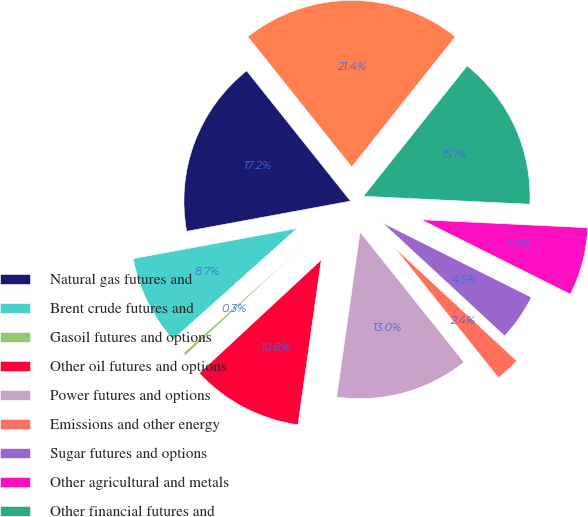Convert chart to OTSL. <chart><loc_0><loc_0><loc_500><loc_500><pie_chart><fcel>Natural gas futures and<fcel>Brent crude futures and<fcel>Gasoil futures and options<fcel>Other oil futures and options<fcel>Power futures and options<fcel>Emissions and other energy<fcel>Sugar futures and options<fcel>Other agricultural and metals<fcel>Other financial futures and<fcel>Total<nl><fcel>17.19%<fcel>8.73%<fcel>0.28%<fcel>10.85%<fcel>12.96%<fcel>2.39%<fcel>4.51%<fcel>6.62%<fcel>15.07%<fcel>21.41%<nl></chart> 